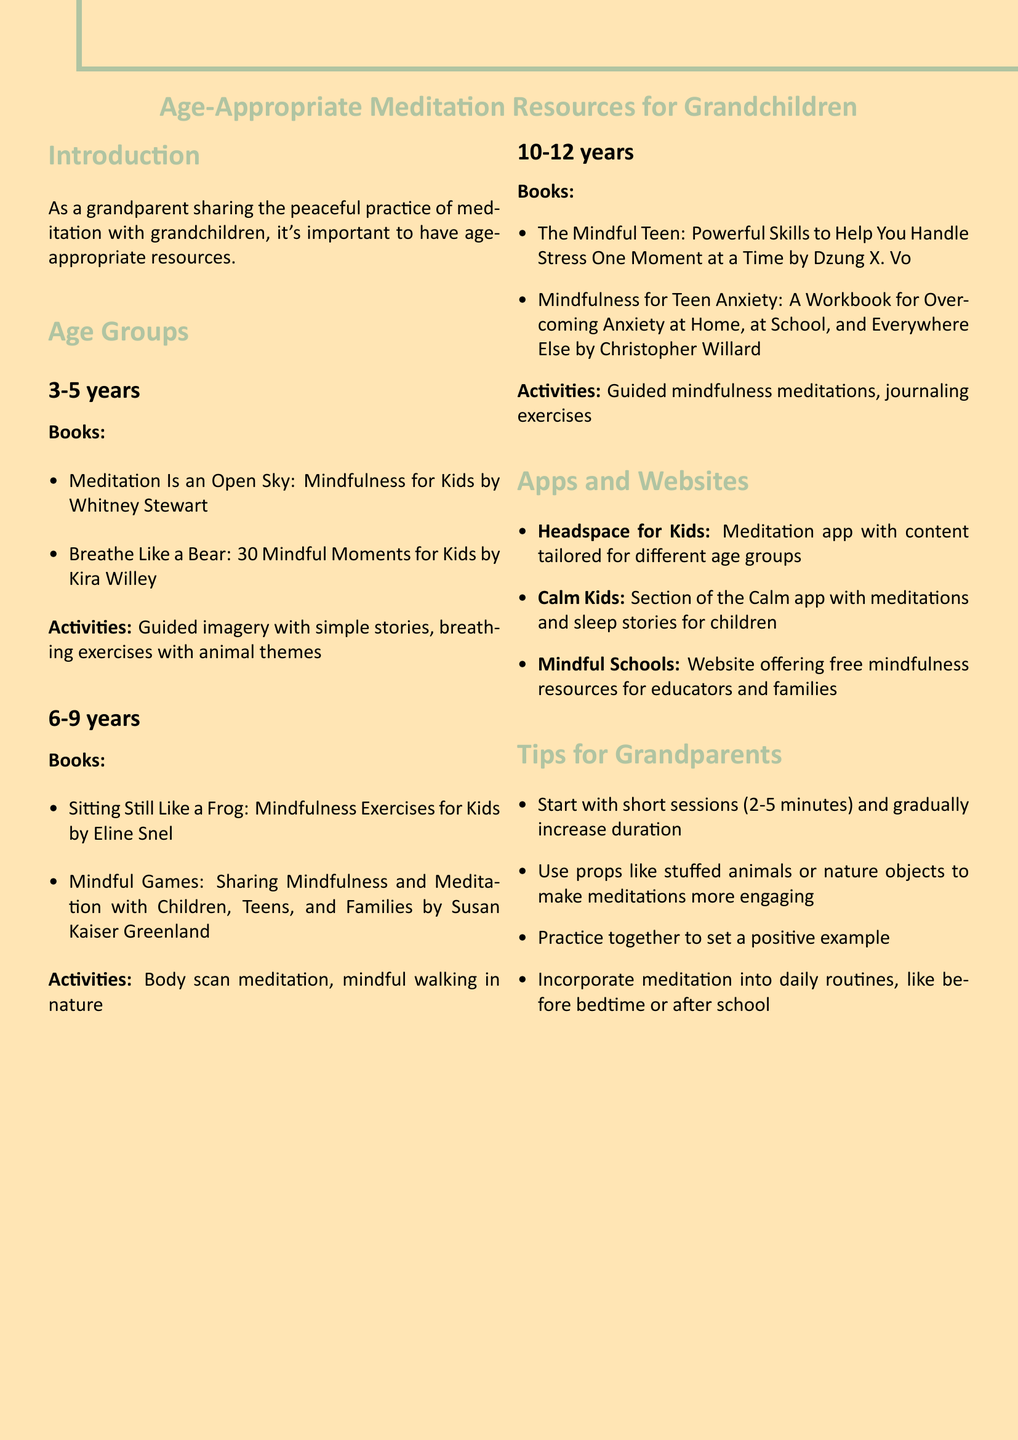What is the title of the document? The title is provided at the beginning of the document, summarizing the content.
Answer: Age-Appropriate Meditation Resources for Grandchildren What is the age range for the first group? The age range for the first group is specified in the age groups section.
Answer: 3-5 years Name one book recommended for ages 6-9. The document lists specific books for each age group, including this age range.
Answer: Sitting Still Like a Frog: Mindfulness Exercises for Kids by Eline Snel What is one activity suggested for children aged 10-12? The document suggests specific activities for each age group, requiring reasoning about the activities listed.
Answer: Guided mindfulness meditations How many apps and websites are mentioned? The document includes a list of resources at the end, providing a count of items listed.
Answer: 3 What is one tip for grandparents included in the document? Tips are listed towards the end, offering guidance for grandparents on how to conduct meditations.
Answer: Start with short sessions (2-5 minutes) and gradually increase duration Which book is recommended for ages 3-5? This question checks the retrieval of a specific book listed under the first age group.
Answer: Meditation Is an Open Sky: Mindfulness for Kids by Whitney Stewart What is the purpose of the document? The introduction summarizes the goal of the resources provided, clarifying its scope and audience.
Answer: To share age-appropriate resources for meditation with grandchildren 